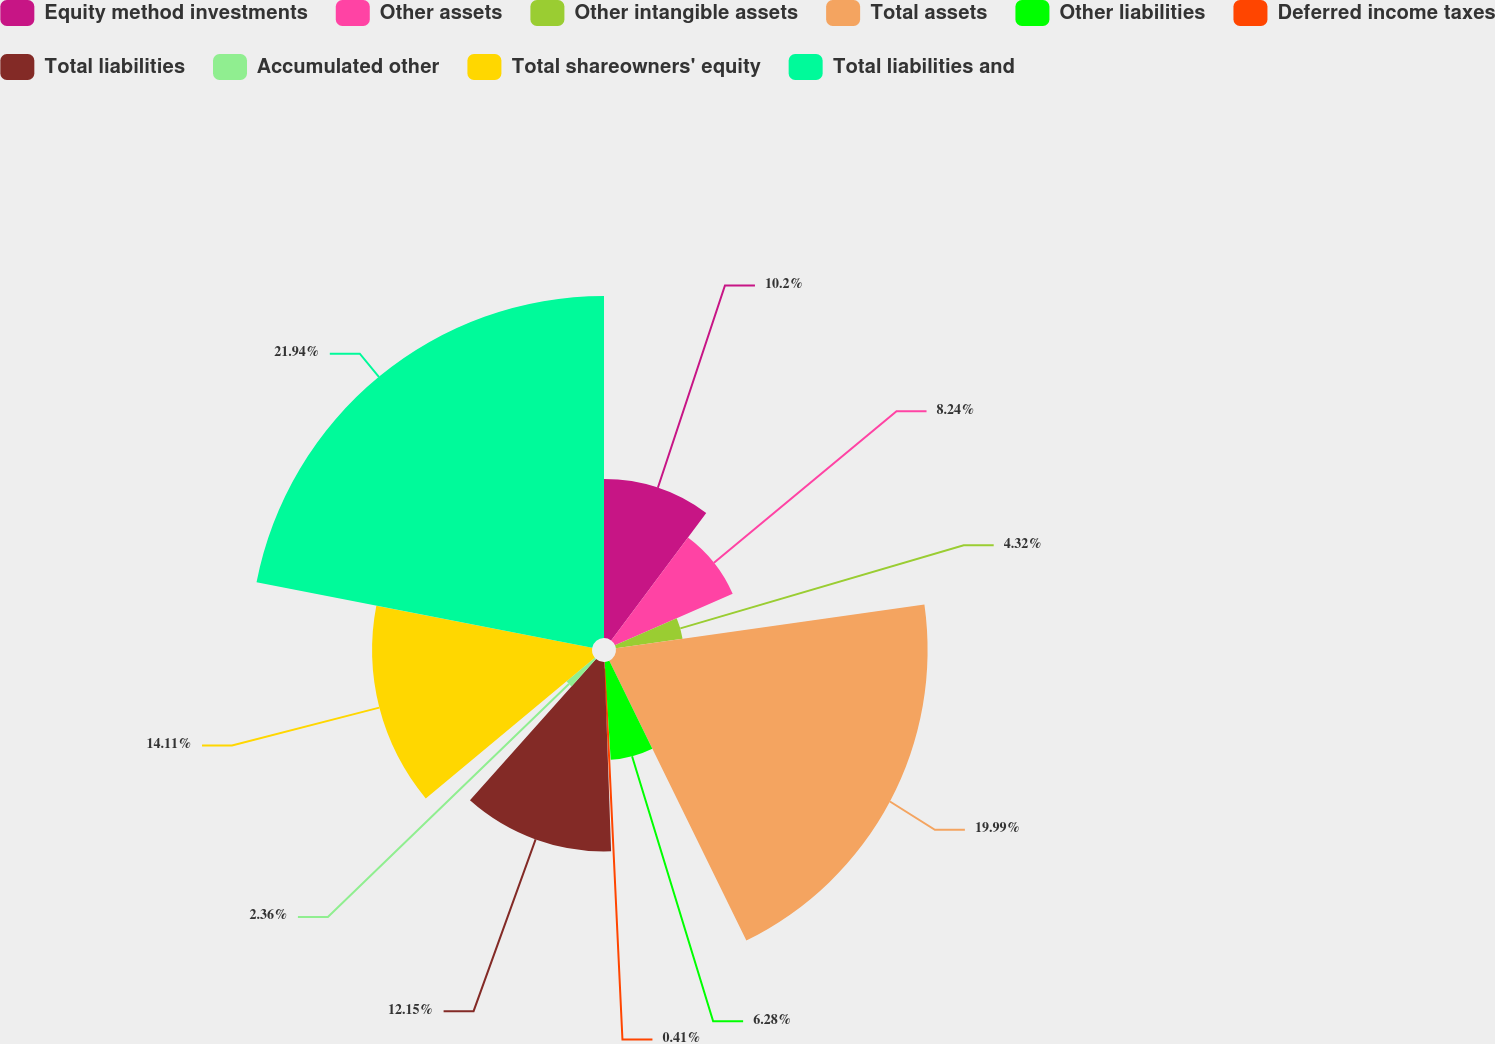Convert chart to OTSL. <chart><loc_0><loc_0><loc_500><loc_500><pie_chart><fcel>Equity method investments<fcel>Other assets<fcel>Other intangible assets<fcel>Total assets<fcel>Other liabilities<fcel>Deferred income taxes<fcel>Total liabilities<fcel>Accumulated other<fcel>Total shareowners' equity<fcel>Total liabilities and<nl><fcel>10.2%<fcel>8.24%<fcel>4.32%<fcel>19.99%<fcel>6.28%<fcel>0.41%<fcel>12.15%<fcel>2.36%<fcel>14.11%<fcel>21.94%<nl></chart> 